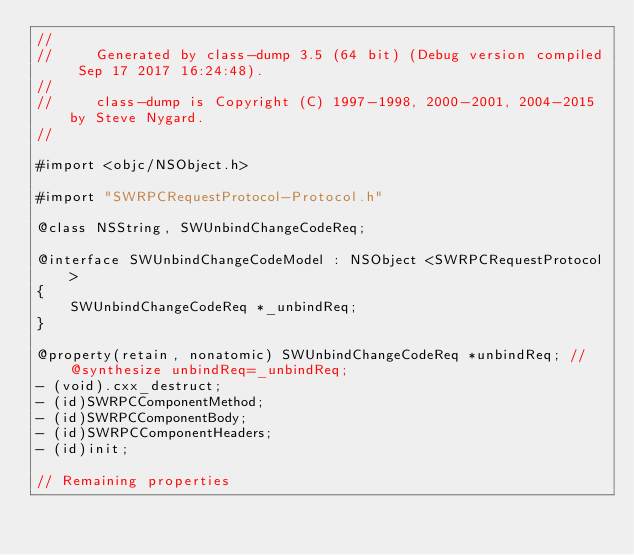Convert code to text. <code><loc_0><loc_0><loc_500><loc_500><_C_>//
//     Generated by class-dump 3.5 (64 bit) (Debug version compiled Sep 17 2017 16:24:48).
//
//     class-dump is Copyright (C) 1997-1998, 2000-2001, 2004-2015 by Steve Nygard.
//

#import <objc/NSObject.h>

#import "SWRPCRequestProtocol-Protocol.h"

@class NSString, SWUnbindChangeCodeReq;

@interface SWUnbindChangeCodeModel : NSObject <SWRPCRequestProtocol>
{
    SWUnbindChangeCodeReq *_unbindReq;
}

@property(retain, nonatomic) SWUnbindChangeCodeReq *unbindReq; // @synthesize unbindReq=_unbindReq;
- (void).cxx_destruct;
- (id)SWRPCComponentMethod;
- (id)SWRPCComponentBody;
- (id)SWRPCComponentHeaders;
- (id)init;

// Remaining properties</code> 